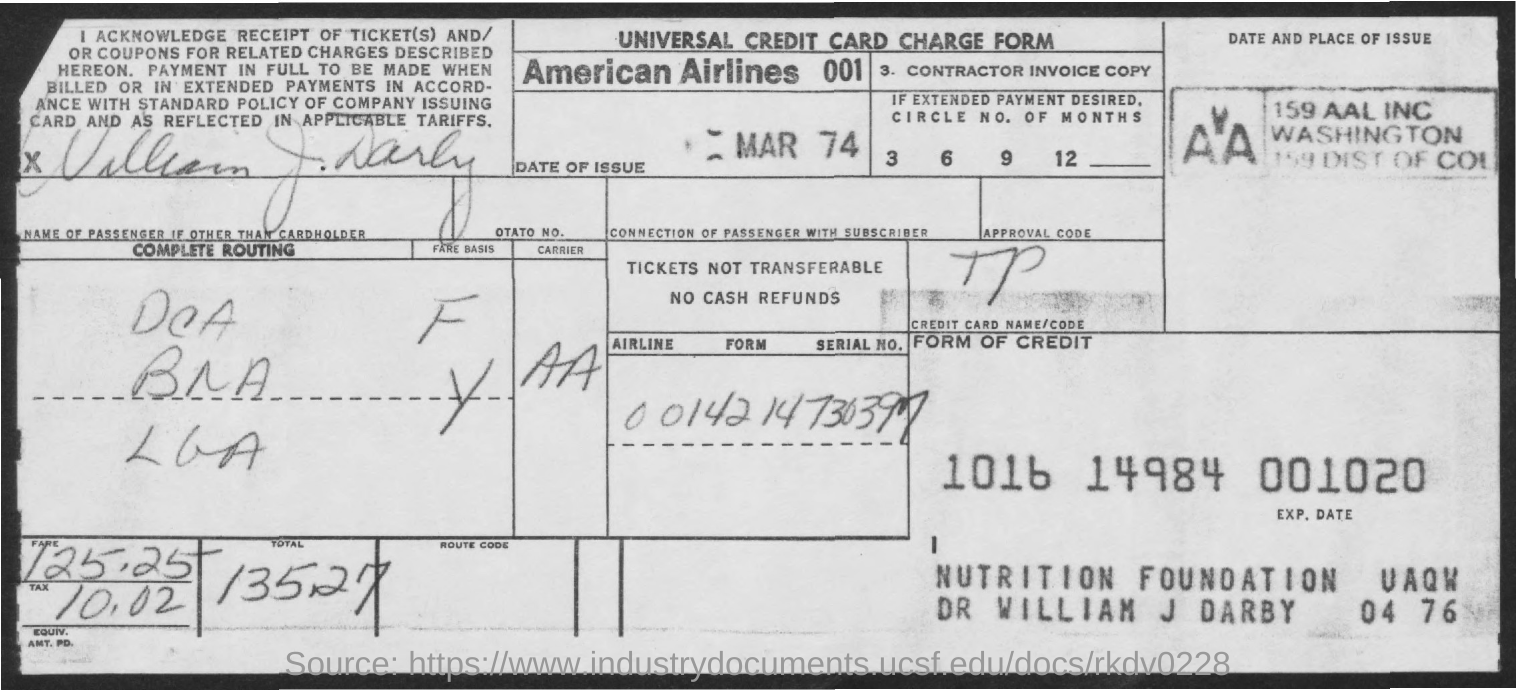Outline some significant characteristics in this image. The tax amount is 10.02. The total amount is 135.27 dollars. The fare amount is 125 for the first 25 units. What is the date of issue for this month and year, specifically March 1974? 